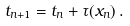Convert formula to latex. <formula><loc_0><loc_0><loc_500><loc_500>t _ { n + 1 } = t _ { n } + \tau ( x _ { n } ) \, .</formula> 